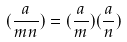<formula> <loc_0><loc_0><loc_500><loc_500>( \frac { a } { m n } ) = ( \frac { a } { m } ) ( \frac { a } { n } )</formula> 